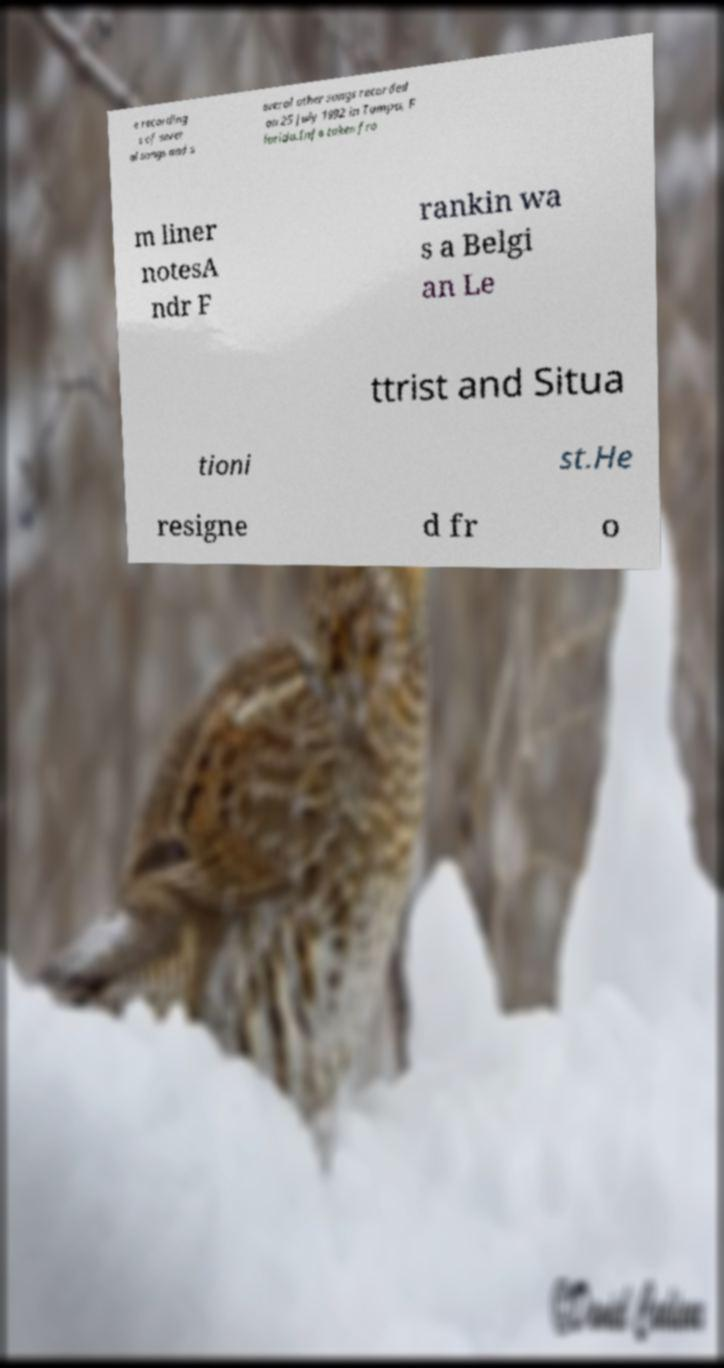Can you read and provide the text displayed in the image?This photo seems to have some interesting text. Can you extract and type it out for me? e recording s of sever al songs and s everal other songs recorded on 25 July 1992 in Tampa, F lorida.Info taken fro m liner notesA ndr F rankin wa s a Belgi an Le ttrist and Situa tioni st.He resigne d fr o 